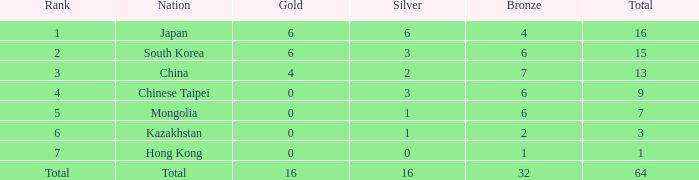Which nation holds a 6th place ranking with no gold medals and less than 6 bronze medals? Kazakhstan. 